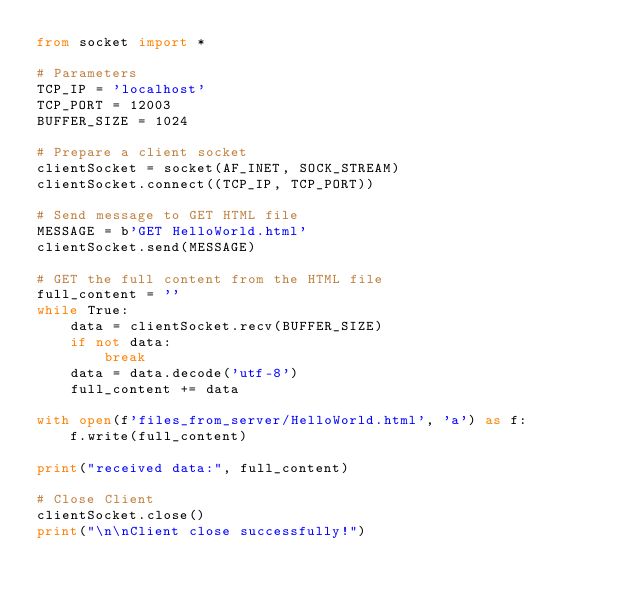<code> <loc_0><loc_0><loc_500><loc_500><_Python_>from socket import *

# Parameters
TCP_IP = 'localhost'
TCP_PORT = 12003
BUFFER_SIZE = 1024

# Prepare a client socket
clientSocket = socket(AF_INET, SOCK_STREAM)
clientSocket.connect((TCP_IP, TCP_PORT))

# Send message to GET HTML file
MESSAGE = b'GET HelloWorld.html'
clientSocket.send(MESSAGE)

# GET the full content from the HTML file
full_content = ''
while True:
    data = clientSocket.recv(BUFFER_SIZE)
    if not data:
        break
    data = data.decode('utf-8')
    full_content += data

with open(f'files_from_server/HelloWorld.html', 'a') as f:
    f.write(full_content)

print("received data:", full_content)

# Close Client
clientSocket.close()
print("\n\nClient close successfully!")

</code> 